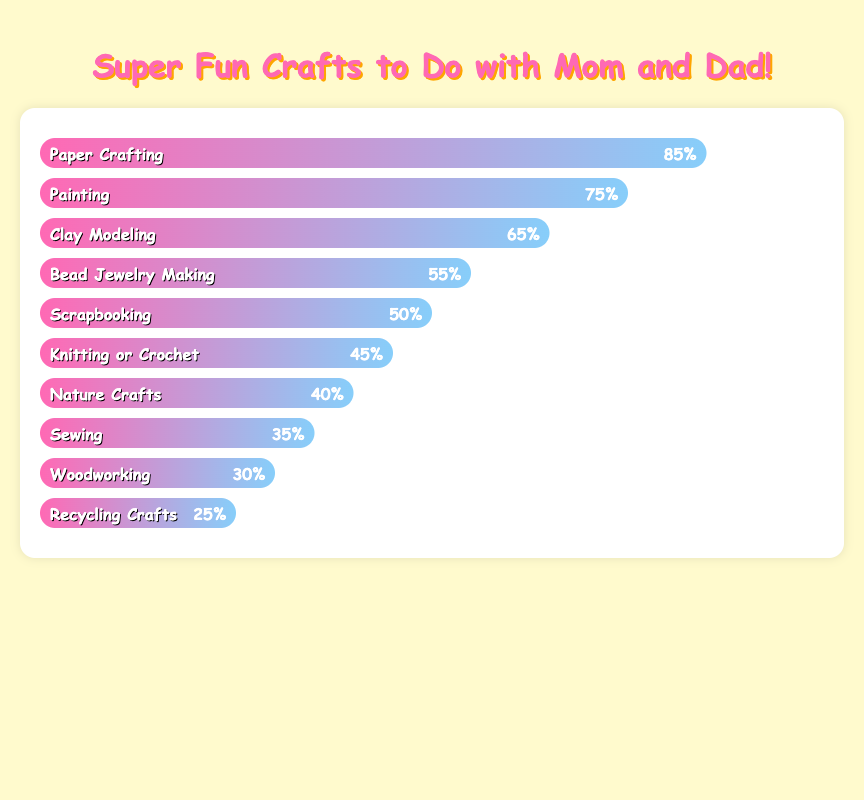What is the most popular craft that parents and children enjoy making together? To find the most popular craft, we need to look at the bar with the highest value. The highest value is 85%, which is for Paper Crafting.
Answer: Paper Crafting Which craft is less popular, Sewing or Nature Crafts? We compare the popularity percentages of Sewing (35%) and Nature Crafts (40%). Sewing has a lower percentage.
Answer: Sewing What is the combined popularity of Painting and Clay Modeling? To find the combined popularity, we add the percentages for Painting (75%) and Clay Modeling (65%). So, 75 + 65 = 140.
Answer: 140% How many crafts have a popularity greater than 50%? We count the bars with percentages greater than 50%. They are Paper Crafting (85%), Painting (75%), Clay Modeling (65%), and Bead Jewelry Making (55%). So, there are 4 crafts.
Answer: 4 What is the difference in popularity between Bead Jewelry Making and Scrapbooking? To find the difference, subtract the percentage of Scrapbooking (50%) from Bead Jewelry Making (55%). So, 55 - 50 = 5.
Answer: 5% What is the average popularity of the least three popular crafts? Add the percentages for the least three popular crafts (Sewing 35%, Woodworking 30%, Recycling Crafts 25%) and divide by 3. So, (35 + 30 + 25) / 3 = 30.
Answer: 30% Which craft has a popularity closest to 70%? We look for the percentage closest to 70%. Clay Modeling has a popularity of 65%, which is closest.
Answer: Clay Modeling Are there more crafts with a popularity below or above 50%? We count the crafts with popularity below 50%: Knitting or Crochet (45%), Nature Crafts (40%), Sewing (35%), Woodworking (30%), and Recycling Crafts (25%) which makes 5. Above 50%, there are 5 crafts as well.
Answer: Equal (5 each) What is the median popularity of all the crafts? First, we list the popularity values in order: 25, 30, 35, 40, 45, 50, 55, 65, 75, 85. The median is the middle value, so the median is the average of the 5th and 6th values (45 + 50) / 2 = 47.5.
Answer: 47.5 Which craft is more popular than Knitting or Crochet but less popular than Painting? We need a craft with a percentage between that of Knitting or Crochet (45%) and Painting (75%). Clay Modeling (65%) fits this range.
Answer: Clay Modeling 